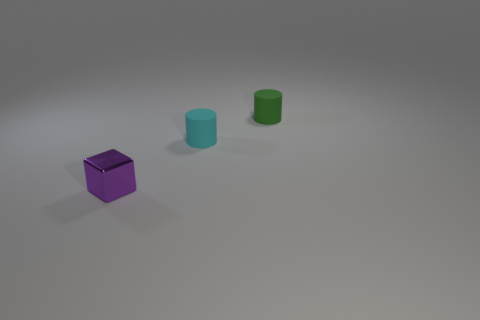Are there an equal number of tiny purple things behind the tiny purple object and tiny cylinders that are in front of the green thing?
Your answer should be compact. No. How many brown objects are cubes or small rubber cylinders?
Provide a succinct answer. 0. What number of purple cubes are the same size as the purple thing?
Offer a terse response. 0. Are there more purple metal blocks on the left side of the green cylinder than red objects?
Your answer should be very brief. Yes. Is there a yellow matte object?
Provide a short and direct response. No. What number of big things are either green rubber cylinders or blue cubes?
Provide a succinct answer. 0. There is a green object that is the same material as the tiny cyan cylinder; what shape is it?
Offer a terse response. Cylinder. What is the shape of the tiny cyan matte object?
Offer a terse response. Cylinder. What shape is the rubber object right of the rubber thing left of the small cylinder that is to the right of the cyan cylinder?
Give a very brief answer. Cylinder. What shape is the rubber thing that is behind the cyan matte thing?
Your answer should be very brief. Cylinder. 